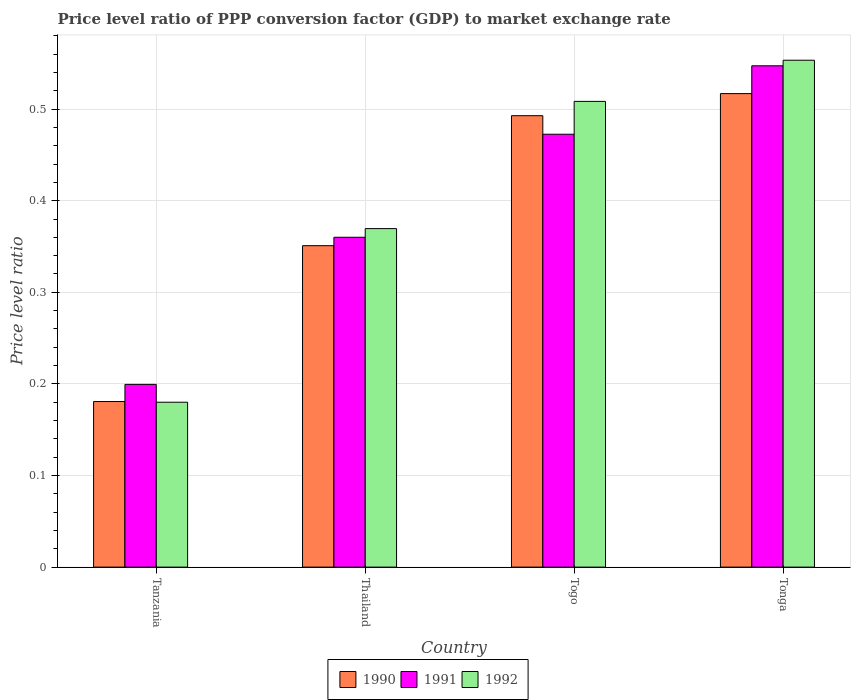How many groups of bars are there?
Make the answer very short. 4. Are the number of bars on each tick of the X-axis equal?
Provide a short and direct response. Yes. How many bars are there on the 2nd tick from the left?
Your response must be concise. 3. What is the label of the 1st group of bars from the left?
Provide a succinct answer. Tanzania. What is the price level ratio in 1992 in Togo?
Your answer should be compact. 0.51. Across all countries, what is the maximum price level ratio in 1992?
Your response must be concise. 0.55. Across all countries, what is the minimum price level ratio in 1992?
Provide a succinct answer. 0.18. In which country was the price level ratio in 1991 maximum?
Provide a short and direct response. Tonga. In which country was the price level ratio in 1990 minimum?
Offer a terse response. Tanzania. What is the total price level ratio in 1992 in the graph?
Your response must be concise. 1.61. What is the difference between the price level ratio in 1992 in Tanzania and that in Togo?
Provide a succinct answer. -0.33. What is the difference between the price level ratio in 1990 in Tanzania and the price level ratio in 1991 in Thailand?
Give a very brief answer. -0.18. What is the average price level ratio in 1991 per country?
Provide a succinct answer. 0.39. What is the difference between the price level ratio of/in 1990 and price level ratio of/in 1991 in Togo?
Give a very brief answer. 0.02. What is the ratio of the price level ratio in 1991 in Togo to that in Tonga?
Ensure brevity in your answer.  0.86. Is the price level ratio in 1990 in Tanzania less than that in Tonga?
Ensure brevity in your answer.  Yes. Is the difference between the price level ratio in 1990 in Tanzania and Thailand greater than the difference between the price level ratio in 1991 in Tanzania and Thailand?
Provide a succinct answer. No. What is the difference between the highest and the second highest price level ratio in 1992?
Your response must be concise. 0.04. What is the difference between the highest and the lowest price level ratio in 1990?
Give a very brief answer. 0.34. Is the sum of the price level ratio in 1992 in Tanzania and Thailand greater than the maximum price level ratio in 1991 across all countries?
Keep it short and to the point. Yes. What does the 1st bar from the left in Tanzania represents?
Keep it short and to the point. 1990. What does the 2nd bar from the right in Tanzania represents?
Your answer should be compact. 1991. How many bars are there?
Keep it short and to the point. 12. What is the difference between two consecutive major ticks on the Y-axis?
Ensure brevity in your answer.  0.1. Does the graph contain grids?
Offer a very short reply. Yes. How are the legend labels stacked?
Your answer should be very brief. Horizontal. What is the title of the graph?
Your response must be concise. Price level ratio of PPP conversion factor (GDP) to market exchange rate. Does "1979" appear as one of the legend labels in the graph?
Your answer should be very brief. No. What is the label or title of the X-axis?
Your answer should be compact. Country. What is the label or title of the Y-axis?
Make the answer very short. Price level ratio. What is the Price level ratio of 1990 in Tanzania?
Make the answer very short. 0.18. What is the Price level ratio of 1991 in Tanzania?
Ensure brevity in your answer.  0.2. What is the Price level ratio of 1992 in Tanzania?
Make the answer very short. 0.18. What is the Price level ratio of 1990 in Thailand?
Give a very brief answer. 0.35. What is the Price level ratio of 1991 in Thailand?
Ensure brevity in your answer.  0.36. What is the Price level ratio of 1992 in Thailand?
Offer a very short reply. 0.37. What is the Price level ratio of 1990 in Togo?
Your response must be concise. 0.49. What is the Price level ratio in 1991 in Togo?
Make the answer very short. 0.47. What is the Price level ratio in 1992 in Togo?
Provide a short and direct response. 0.51. What is the Price level ratio of 1990 in Tonga?
Keep it short and to the point. 0.52. What is the Price level ratio of 1991 in Tonga?
Offer a terse response. 0.55. What is the Price level ratio of 1992 in Tonga?
Your answer should be very brief. 0.55. Across all countries, what is the maximum Price level ratio in 1990?
Offer a very short reply. 0.52. Across all countries, what is the maximum Price level ratio of 1991?
Your answer should be compact. 0.55. Across all countries, what is the maximum Price level ratio of 1992?
Offer a very short reply. 0.55. Across all countries, what is the minimum Price level ratio of 1990?
Keep it short and to the point. 0.18. Across all countries, what is the minimum Price level ratio of 1991?
Your answer should be very brief. 0.2. Across all countries, what is the minimum Price level ratio of 1992?
Provide a short and direct response. 0.18. What is the total Price level ratio in 1990 in the graph?
Give a very brief answer. 1.54. What is the total Price level ratio of 1991 in the graph?
Give a very brief answer. 1.58. What is the total Price level ratio in 1992 in the graph?
Make the answer very short. 1.61. What is the difference between the Price level ratio in 1990 in Tanzania and that in Thailand?
Give a very brief answer. -0.17. What is the difference between the Price level ratio of 1991 in Tanzania and that in Thailand?
Your answer should be very brief. -0.16. What is the difference between the Price level ratio in 1992 in Tanzania and that in Thailand?
Provide a succinct answer. -0.19. What is the difference between the Price level ratio of 1990 in Tanzania and that in Togo?
Make the answer very short. -0.31. What is the difference between the Price level ratio of 1991 in Tanzania and that in Togo?
Offer a terse response. -0.27. What is the difference between the Price level ratio of 1992 in Tanzania and that in Togo?
Provide a short and direct response. -0.33. What is the difference between the Price level ratio of 1990 in Tanzania and that in Tonga?
Make the answer very short. -0.34. What is the difference between the Price level ratio in 1991 in Tanzania and that in Tonga?
Your answer should be compact. -0.35. What is the difference between the Price level ratio in 1992 in Tanzania and that in Tonga?
Provide a succinct answer. -0.37. What is the difference between the Price level ratio in 1990 in Thailand and that in Togo?
Your response must be concise. -0.14. What is the difference between the Price level ratio in 1991 in Thailand and that in Togo?
Offer a very short reply. -0.11. What is the difference between the Price level ratio of 1992 in Thailand and that in Togo?
Ensure brevity in your answer.  -0.14. What is the difference between the Price level ratio of 1990 in Thailand and that in Tonga?
Your answer should be compact. -0.17. What is the difference between the Price level ratio of 1991 in Thailand and that in Tonga?
Provide a short and direct response. -0.19. What is the difference between the Price level ratio of 1992 in Thailand and that in Tonga?
Offer a terse response. -0.18. What is the difference between the Price level ratio in 1990 in Togo and that in Tonga?
Your answer should be very brief. -0.02. What is the difference between the Price level ratio of 1991 in Togo and that in Tonga?
Your answer should be very brief. -0.07. What is the difference between the Price level ratio of 1992 in Togo and that in Tonga?
Offer a very short reply. -0.04. What is the difference between the Price level ratio in 1990 in Tanzania and the Price level ratio in 1991 in Thailand?
Your response must be concise. -0.18. What is the difference between the Price level ratio of 1990 in Tanzania and the Price level ratio of 1992 in Thailand?
Offer a very short reply. -0.19. What is the difference between the Price level ratio in 1991 in Tanzania and the Price level ratio in 1992 in Thailand?
Ensure brevity in your answer.  -0.17. What is the difference between the Price level ratio in 1990 in Tanzania and the Price level ratio in 1991 in Togo?
Ensure brevity in your answer.  -0.29. What is the difference between the Price level ratio in 1990 in Tanzania and the Price level ratio in 1992 in Togo?
Give a very brief answer. -0.33. What is the difference between the Price level ratio of 1991 in Tanzania and the Price level ratio of 1992 in Togo?
Give a very brief answer. -0.31. What is the difference between the Price level ratio of 1990 in Tanzania and the Price level ratio of 1991 in Tonga?
Ensure brevity in your answer.  -0.37. What is the difference between the Price level ratio in 1990 in Tanzania and the Price level ratio in 1992 in Tonga?
Keep it short and to the point. -0.37. What is the difference between the Price level ratio of 1991 in Tanzania and the Price level ratio of 1992 in Tonga?
Offer a very short reply. -0.35. What is the difference between the Price level ratio in 1990 in Thailand and the Price level ratio in 1991 in Togo?
Offer a terse response. -0.12. What is the difference between the Price level ratio in 1990 in Thailand and the Price level ratio in 1992 in Togo?
Offer a very short reply. -0.16. What is the difference between the Price level ratio in 1991 in Thailand and the Price level ratio in 1992 in Togo?
Provide a succinct answer. -0.15. What is the difference between the Price level ratio in 1990 in Thailand and the Price level ratio in 1991 in Tonga?
Make the answer very short. -0.2. What is the difference between the Price level ratio of 1990 in Thailand and the Price level ratio of 1992 in Tonga?
Provide a short and direct response. -0.2. What is the difference between the Price level ratio of 1991 in Thailand and the Price level ratio of 1992 in Tonga?
Ensure brevity in your answer.  -0.19. What is the difference between the Price level ratio in 1990 in Togo and the Price level ratio in 1991 in Tonga?
Ensure brevity in your answer.  -0.05. What is the difference between the Price level ratio of 1990 in Togo and the Price level ratio of 1992 in Tonga?
Offer a very short reply. -0.06. What is the difference between the Price level ratio in 1991 in Togo and the Price level ratio in 1992 in Tonga?
Offer a terse response. -0.08. What is the average Price level ratio of 1990 per country?
Give a very brief answer. 0.39. What is the average Price level ratio of 1991 per country?
Offer a very short reply. 0.39. What is the average Price level ratio of 1992 per country?
Make the answer very short. 0.4. What is the difference between the Price level ratio in 1990 and Price level ratio in 1991 in Tanzania?
Make the answer very short. -0.02. What is the difference between the Price level ratio of 1990 and Price level ratio of 1992 in Tanzania?
Keep it short and to the point. 0. What is the difference between the Price level ratio in 1991 and Price level ratio in 1992 in Tanzania?
Your response must be concise. 0.02. What is the difference between the Price level ratio in 1990 and Price level ratio in 1991 in Thailand?
Make the answer very short. -0.01. What is the difference between the Price level ratio of 1990 and Price level ratio of 1992 in Thailand?
Ensure brevity in your answer.  -0.02. What is the difference between the Price level ratio of 1991 and Price level ratio of 1992 in Thailand?
Ensure brevity in your answer.  -0.01. What is the difference between the Price level ratio of 1990 and Price level ratio of 1991 in Togo?
Ensure brevity in your answer.  0.02. What is the difference between the Price level ratio in 1990 and Price level ratio in 1992 in Togo?
Offer a very short reply. -0.02. What is the difference between the Price level ratio in 1991 and Price level ratio in 1992 in Togo?
Provide a succinct answer. -0.04. What is the difference between the Price level ratio in 1990 and Price level ratio in 1991 in Tonga?
Give a very brief answer. -0.03. What is the difference between the Price level ratio of 1990 and Price level ratio of 1992 in Tonga?
Provide a succinct answer. -0.04. What is the difference between the Price level ratio of 1991 and Price level ratio of 1992 in Tonga?
Your answer should be compact. -0.01. What is the ratio of the Price level ratio of 1990 in Tanzania to that in Thailand?
Offer a very short reply. 0.52. What is the ratio of the Price level ratio in 1991 in Tanzania to that in Thailand?
Your answer should be very brief. 0.55. What is the ratio of the Price level ratio in 1992 in Tanzania to that in Thailand?
Make the answer very short. 0.49. What is the ratio of the Price level ratio in 1990 in Tanzania to that in Togo?
Keep it short and to the point. 0.37. What is the ratio of the Price level ratio in 1991 in Tanzania to that in Togo?
Provide a succinct answer. 0.42. What is the ratio of the Price level ratio of 1992 in Tanzania to that in Togo?
Your answer should be very brief. 0.35. What is the ratio of the Price level ratio of 1990 in Tanzania to that in Tonga?
Your answer should be compact. 0.35. What is the ratio of the Price level ratio of 1991 in Tanzania to that in Tonga?
Ensure brevity in your answer.  0.36. What is the ratio of the Price level ratio of 1992 in Tanzania to that in Tonga?
Your answer should be very brief. 0.33. What is the ratio of the Price level ratio in 1990 in Thailand to that in Togo?
Offer a very short reply. 0.71. What is the ratio of the Price level ratio in 1991 in Thailand to that in Togo?
Ensure brevity in your answer.  0.76. What is the ratio of the Price level ratio in 1992 in Thailand to that in Togo?
Keep it short and to the point. 0.73. What is the ratio of the Price level ratio of 1990 in Thailand to that in Tonga?
Your answer should be compact. 0.68. What is the ratio of the Price level ratio in 1991 in Thailand to that in Tonga?
Your answer should be very brief. 0.66. What is the ratio of the Price level ratio of 1992 in Thailand to that in Tonga?
Your response must be concise. 0.67. What is the ratio of the Price level ratio in 1990 in Togo to that in Tonga?
Offer a terse response. 0.95. What is the ratio of the Price level ratio of 1991 in Togo to that in Tonga?
Give a very brief answer. 0.86. What is the ratio of the Price level ratio in 1992 in Togo to that in Tonga?
Your response must be concise. 0.92. What is the difference between the highest and the second highest Price level ratio in 1990?
Provide a short and direct response. 0.02. What is the difference between the highest and the second highest Price level ratio of 1991?
Give a very brief answer. 0.07. What is the difference between the highest and the second highest Price level ratio in 1992?
Make the answer very short. 0.04. What is the difference between the highest and the lowest Price level ratio of 1990?
Keep it short and to the point. 0.34. What is the difference between the highest and the lowest Price level ratio in 1991?
Keep it short and to the point. 0.35. What is the difference between the highest and the lowest Price level ratio of 1992?
Your response must be concise. 0.37. 